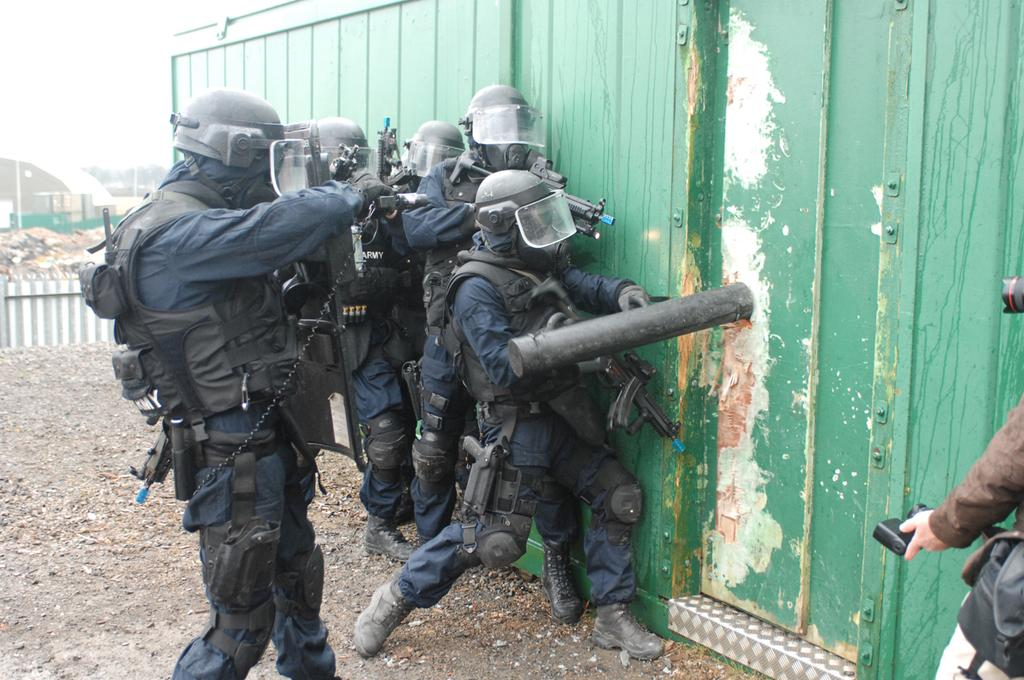What are the people in the image holding? The people in the image are holding guns. What type of structure can be seen in the image? There is a wall in the image. Are there any openings in the wall? Yes, there are doors in the image. What type of vegetation is visible in the image? There are trees in the image. What else can be seen in the image besides the people, wall, doors, and trees? There are poles in the image. What is visible in the background of the image? The sky is visible in the background of the image. Can you tell me how many cubs are playing with the monkey in the image? There are no cubs or monkeys present in the image. 